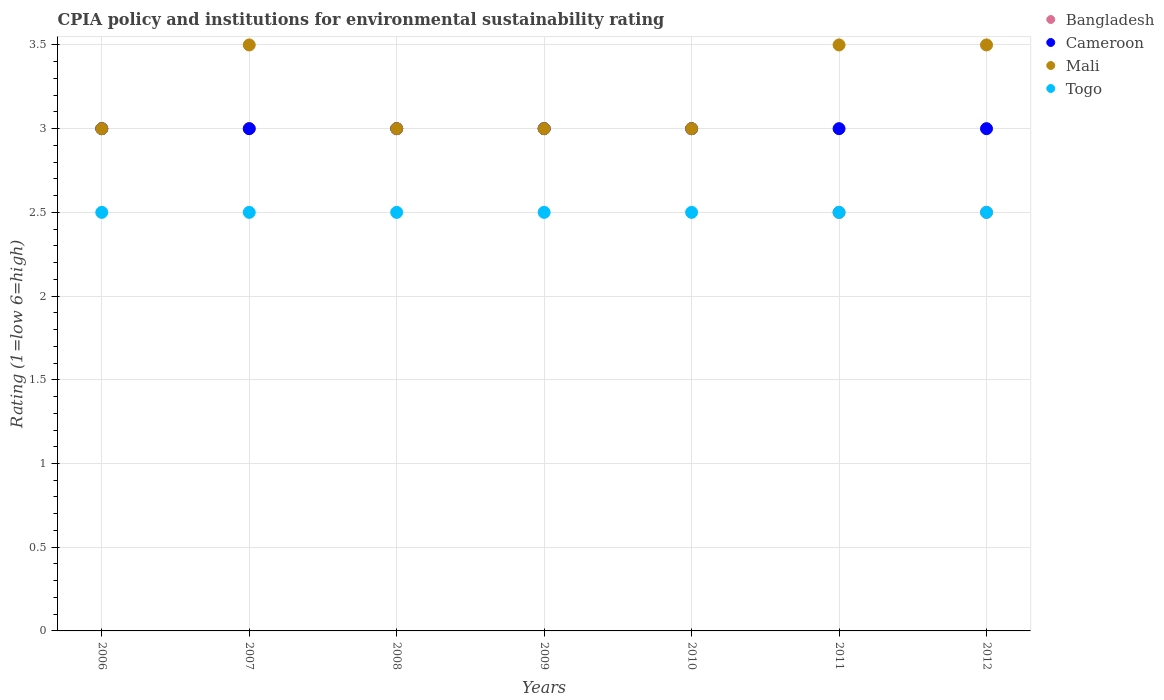Is the number of dotlines equal to the number of legend labels?
Your response must be concise. Yes. What is the CPIA rating in Mali in 2010?
Give a very brief answer. 3. Across all years, what is the maximum CPIA rating in Cameroon?
Provide a short and direct response. 3. Across all years, what is the minimum CPIA rating in Cameroon?
Give a very brief answer. 3. In which year was the CPIA rating in Togo minimum?
Keep it short and to the point. 2006. What is the total CPIA rating in Cameroon in the graph?
Keep it short and to the point. 21. What is the difference between the CPIA rating in Mali in 2011 and the CPIA rating in Togo in 2007?
Your answer should be very brief. 1. In how many years, is the CPIA rating in Bangladesh greater than 3?
Provide a short and direct response. 0. Is the difference between the CPIA rating in Togo in 2006 and 2012 greater than the difference between the CPIA rating in Cameroon in 2006 and 2012?
Give a very brief answer. No. What is the difference between the highest and the lowest CPIA rating in Cameroon?
Provide a succinct answer. 0. Is it the case that in every year, the sum of the CPIA rating in Cameroon and CPIA rating in Mali  is greater than the CPIA rating in Togo?
Offer a very short reply. Yes. Is the CPIA rating in Togo strictly less than the CPIA rating in Mali over the years?
Offer a terse response. Yes. How many dotlines are there?
Your answer should be very brief. 4. Are the values on the major ticks of Y-axis written in scientific E-notation?
Keep it short and to the point. No. Does the graph contain any zero values?
Offer a very short reply. No. Does the graph contain grids?
Your answer should be very brief. Yes. How many legend labels are there?
Your answer should be very brief. 4. What is the title of the graph?
Offer a terse response. CPIA policy and institutions for environmental sustainability rating. What is the Rating (1=low 6=high) in Bangladesh in 2006?
Provide a short and direct response. 3. What is the Rating (1=low 6=high) in Mali in 2006?
Your response must be concise. 3. What is the Rating (1=low 6=high) of Bangladesh in 2007?
Your answer should be compact. 3. What is the Rating (1=low 6=high) of Cameroon in 2008?
Make the answer very short. 3. What is the Rating (1=low 6=high) of Mali in 2008?
Keep it short and to the point. 3. What is the Rating (1=low 6=high) in Togo in 2008?
Ensure brevity in your answer.  2.5. What is the Rating (1=low 6=high) of Cameroon in 2010?
Make the answer very short. 3. What is the Rating (1=low 6=high) of Mali in 2010?
Offer a very short reply. 3. What is the Rating (1=low 6=high) in Togo in 2011?
Ensure brevity in your answer.  2.5. What is the Rating (1=low 6=high) of Cameroon in 2012?
Make the answer very short. 3. What is the Rating (1=low 6=high) of Mali in 2012?
Give a very brief answer. 3.5. Across all years, what is the maximum Rating (1=low 6=high) in Bangladesh?
Make the answer very short. 3. Across all years, what is the maximum Rating (1=low 6=high) in Mali?
Give a very brief answer. 3.5. Across all years, what is the maximum Rating (1=low 6=high) in Togo?
Provide a succinct answer. 2.5. Across all years, what is the minimum Rating (1=low 6=high) in Bangladesh?
Offer a very short reply. 2.5. Across all years, what is the minimum Rating (1=low 6=high) of Cameroon?
Make the answer very short. 3. Across all years, what is the minimum Rating (1=low 6=high) in Mali?
Provide a succinct answer. 3. Across all years, what is the minimum Rating (1=low 6=high) of Togo?
Your answer should be compact. 2.5. What is the total Rating (1=low 6=high) in Cameroon in the graph?
Provide a short and direct response. 21. What is the total Rating (1=low 6=high) in Togo in the graph?
Offer a terse response. 17.5. What is the difference between the Rating (1=low 6=high) of Bangladesh in 2006 and that in 2007?
Provide a short and direct response. 0. What is the difference between the Rating (1=low 6=high) of Cameroon in 2006 and that in 2008?
Provide a succinct answer. 0. What is the difference between the Rating (1=low 6=high) in Mali in 2006 and that in 2008?
Provide a succinct answer. 0. What is the difference between the Rating (1=low 6=high) of Mali in 2006 and that in 2009?
Offer a terse response. 0. What is the difference between the Rating (1=low 6=high) in Cameroon in 2006 and that in 2010?
Ensure brevity in your answer.  0. What is the difference between the Rating (1=low 6=high) in Bangladesh in 2006 and that in 2011?
Your response must be concise. 0.5. What is the difference between the Rating (1=low 6=high) of Togo in 2006 and that in 2011?
Offer a terse response. 0. What is the difference between the Rating (1=low 6=high) in Togo in 2006 and that in 2012?
Your answer should be very brief. 0. What is the difference between the Rating (1=low 6=high) of Mali in 2007 and that in 2008?
Offer a terse response. 0.5. What is the difference between the Rating (1=low 6=high) of Bangladesh in 2007 and that in 2009?
Make the answer very short. 0. What is the difference between the Rating (1=low 6=high) of Togo in 2007 and that in 2009?
Offer a terse response. 0. What is the difference between the Rating (1=low 6=high) in Bangladesh in 2007 and that in 2010?
Your response must be concise. 0. What is the difference between the Rating (1=low 6=high) of Cameroon in 2007 and that in 2010?
Keep it short and to the point. 0. What is the difference between the Rating (1=low 6=high) in Mali in 2007 and that in 2010?
Your response must be concise. 0.5. What is the difference between the Rating (1=low 6=high) in Cameroon in 2007 and that in 2011?
Offer a very short reply. 0. What is the difference between the Rating (1=low 6=high) in Mali in 2007 and that in 2011?
Offer a terse response. 0. What is the difference between the Rating (1=low 6=high) of Togo in 2007 and that in 2011?
Your response must be concise. 0. What is the difference between the Rating (1=low 6=high) in Bangladesh in 2007 and that in 2012?
Your answer should be very brief. 0.5. What is the difference between the Rating (1=low 6=high) of Mali in 2007 and that in 2012?
Your answer should be very brief. 0. What is the difference between the Rating (1=low 6=high) in Cameroon in 2008 and that in 2009?
Your answer should be compact. 0. What is the difference between the Rating (1=low 6=high) of Togo in 2008 and that in 2009?
Give a very brief answer. 0. What is the difference between the Rating (1=low 6=high) of Bangladesh in 2008 and that in 2010?
Your response must be concise. 0. What is the difference between the Rating (1=low 6=high) of Cameroon in 2008 and that in 2010?
Ensure brevity in your answer.  0. What is the difference between the Rating (1=low 6=high) of Mali in 2008 and that in 2010?
Keep it short and to the point. 0. What is the difference between the Rating (1=low 6=high) in Togo in 2008 and that in 2010?
Provide a succinct answer. 0. What is the difference between the Rating (1=low 6=high) of Cameroon in 2008 and that in 2012?
Ensure brevity in your answer.  0. What is the difference between the Rating (1=low 6=high) in Mali in 2008 and that in 2012?
Make the answer very short. -0.5. What is the difference between the Rating (1=low 6=high) of Togo in 2008 and that in 2012?
Your answer should be very brief. 0. What is the difference between the Rating (1=low 6=high) of Cameroon in 2009 and that in 2010?
Ensure brevity in your answer.  0. What is the difference between the Rating (1=low 6=high) in Cameroon in 2009 and that in 2011?
Offer a terse response. 0. What is the difference between the Rating (1=low 6=high) in Mali in 2009 and that in 2011?
Ensure brevity in your answer.  -0.5. What is the difference between the Rating (1=low 6=high) of Togo in 2009 and that in 2011?
Provide a short and direct response. 0. What is the difference between the Rating (1=low 6=high) in Cameroon in 2009 and that in 2012?
Give a very brief answer. 0. What is the difference between the Rating (1=low 6=high) of Togo in 2009 and that in 2012?
Your response must be concise. 0. What is the difference between the Rating (1=low 6=high) of Cameroon in 2010 and that in 2011?
Keep it short and to the point. 0. What is the difference between the Rating (1=low 6=high) of Mali in 2010 and that in 2011?
Provide a succinct answer. -0.5. What is the difference between the Rating (1=low 6=high) in Bangladesh in 2010 and that in 2012?
Your answer should be very brief. 0.5. What is the difference between the Rating (1=low 6=high) in Cameroon in 2010 and that in 2012?
Give a very brief answer. 0. What is the difference between the Rating (1=low 6=high) in Cameroon in 2011 and that in 2012?
Give a very brief answer. 0. What is the difference between the Rating (1=low 6=high) of Bangladesh in 2006 and the Rating (1=low 6=high) of Cameroon in 2007?
Ensure brevity in your answer.  0. What is the difference between the Rating (1=low 6=high) in Bangladesh in 2006 and the Rating (1=low 6=high) in Mali in 2007?
Keep it short and to the point. -0.5. What is the difference between the Rating (1=low 6=high) in Bangladesh in 2006 and the Rating (1=low 6=high) in Togo in 2007?
Your answer should be compact. 0.5. What is the difference between the Rating (1=low 6=high) in Cameroon in 2006 and the Rating (1=low 6=high) in Mali in 2007?
Make the answer very short. -0.5. What is the difference between the Rating (1=low 6=high) in Bangladesh in 2006 and the Rating (1=low 6=high) in Cameroon in 2008?
Your response must be concise. 0. What is the difference between the Rating (1=low 6=high) of Bangladesh in 2006 and the Rating (1=low 6=high) of Mali in 2008?
Provide a short and direct response. 0. What is the difference between the Rating (1=low 6=high) of Cameroon in 2006 and the Rating (1=low 6=high) of Mali in 2008?
Make the answer very short. 0. What is the difference between the Rating (1=low 6=high) in Mali in 2006 and the Rating (1=low 6=high) in Togo in 2008?
Give a very brief answer. 0.5. What is the difference between the Rating (1=low 6=high) in Bangladesh in 2006 and the Rating (1=low 6=high) in Cameroon in 2009?
Provide a short and direct response. 0. What is the difference between the Rating (1=low 6=high) in Bangladesh in 2006 and the Rating (1=low 6=high) in Mali in 2009?
Your response must be concise. 0. What is the difference between the Rating (1=low 6=high) of Bangladesh in 2006 and the Rating (1=low 6=high) of Togo in 2009?
Ensure brevity in your answer.  0.5. What is the difference between the Rating (1=low 6=high) in Cameroon in 2006 and the Rating (1=low 6=high) in Mali in 2009?
Your response must be concise. 0. What is the difference between the Rating (1=low 6=high) of Bangladesh in 2006 and the Rating (1=low 6=high) of Cameroon in 2010?
Provide a succinct answer. 0. What is the difference between the Rating (1=low 6=high) in Bangladesh in 2006 and the Rating (1=low 6=high) in Mali in 2010?
Offer a very short reply. 0. What is the difference between the Rating (1=low 6=high) in Bangladesh in 2006 and the Rating (1=low 6=high) in Togo in 2010?
Give a very brief answer. 0.5. What is the difference between the Rating (1=low 6=high) in Cameroon in 2006 and the Rating (1=low 6=high) in Mali in 2010?
Offer a terse response. 0. What is the difference between the Rating (1=low 6=high) of Mali in 2006 and the Rating (1=low 6=high) of Togo in 2010?
Offer a terse response. 0.5. What is the difference between the Rating (1=low 6=high) of Bangladesh in 2006 and the Rating (1=low 6=high) of Mali in 2011?
Provide a succinct answer. -0.5. What is the difference between the Rating (1=low 6=high) of Cameroon in 2006 and the Rating (1=low 6=high) of Mali in 2011?
Offer a very short reply. -0.5. What is the difference between the Rating (1=low 6=high) of Cameroon in 2006 and the Rating (1=low 6=high) of Togo in 2011?
Your answer should be very brief. 0.5. What is the difference between the Rating (1=low 6=high) in Bangladesh in 2006 and the Rating (1=low 6=high) in Cameroon in 2012?
Provide a succinct answer. 0. What is the difference between the Rating (1=low 6=high) of Bangladesh in 2006 and the Rating (1=low 6=high) of Mali in 2012?
Offer a very short reply. -0.5. What is the difference between the Rating (1=low 6=high) of Bangladesh in 2006 and the Rating (1=low 6=high) of Togo in 2012?
Keep it short and to the point. 0.5. What is the difference between the Rating (1=low 6=high) of Cameroon in 2006 and the Rating (1=low 6=high) of Togo in 2012?
Offer a terse response. 0.5. What is the difference between the Rating (1=low 6=high) of Bangladesh in 2007 and the Rating (1=low 6=high) of Togo in 2008?
Keep it short and to the point. 0.5. What is the difference between the Rating (1=low 6=high) of Cameroon in 2007 and the Rating (1=low 6=high) of Mali in 2008?
Provide a succinct answer. 0. What is the difference between the Rating (1=low 6=high) of Cameroon in 2007 and the Rating (1=low 6=high) of Togo in 2008?
Offer a very short reply. 0.5. What is the difference between the Rating (1=low 6=high) in Bangladesh in 2007 and the Rating (1=low 6=high) in Cameroon in 2010?
Keep it short and to the point. 0. What is the difference between the Rating (1=low 6=high) of Bangladesh in 2007 and the Rating (1=low 6=high) of Mali in 2010?
Ensure brevity in your answer.  0. What is the difference between the Rating (1=low 6=high) of Bangladesh in 2007 and the Rating (1=low 6=high) of Mali in 2011?
Give a very brief answer. -0.5. What is the difference between the Rating (1=low 6=high) in Bangladesh in 2007 and the Rating (1=low 6=high) in Togo in 2011?
Your answer should be compact. 0.5. What is the difference between the Rating (1=low 6=high) in Cameroon in 2007 and the Rating (1=low 6=high) in Mali in 2011?
Your answer should be very brief. -0.5. What is the difference between the Rating (1=low 6=high) of Cameroon in 2007 and the Rating (1=low 6=high) of Mali in 2012?
Your response must be concise. -0.5. What is the difference between the Rating (1=low 6=high) in Cameroon in 2007 and the Rating (1=low 6=high) in Togo in 2012?
Your answer should be very brief. 0.5. What is the difference between the Rating (1=low 6=high) in Mali in 2007 and the Rating (1=low 6=high) in Togo in 2012?
Give a very brief answer. 1. What is the difference between the Rating (1=low 6=high) of Bangladesh in 2008 and the Rating (1=low 6=high) of Cameroon in 2009?
Make the answer very short. 0. What is the difference between the Rating (1=low 6=high) in Cameroon in 2008 and the Rating (1=low 6=high) in Mali in 2009?
Offer a terse response. 0. What is the difference between the Rating (1=low 6=high) in Bangladesh in 2008 and the Rating (1=low 6=high) in Togo in 2010?
Offer a very short reply. 0.5. What is the difference between the Rating (1=low 6=high) of Cameroon in 2008 and the Rating (1=low 6=high) of Mali in 2010?
Ensure brevity in your answer.  0. What is the difference between the Rating (1=low 6=high) in Mali in 2008 and the Rating (1=low 6=high) in Togo in 2010?
Ensure brevity in your answer.  0.5. What is the difference between the Rating (1=low 6=high) of Bangladesh in 2008 and the Rating (1=low 6=high) of Cameroon in 2011?
Keep it short and to the point. 0. What is the difference between the Rating (1=low 6=high) of Bangladesh in 2008 and the Rating (1=low 6=high) of Mali in 2011?
Provide a succinct answer. -0.5. What is the difference between the Rating (1=low 6=high) in Mali in 2008 and the Rating (1=low 6=high) in Togo in 2011?
Keep it short and to the point. 0.5. What is the difference between the Rating (1=low 6=high) in Bangladesh in 2008 and the Rating (1=low 6=high) in Mali in 2012?
Your response must be concise. -0.5. What is the difference between the Rating (1=low 6=high) in Bangladesh in 2008 and the Rating (1=low 6=high) in Togo in 2012?
Offer a very short reply. 0.5. What is the difference between the Rating (1=low 6=high) in Cameroon in 2008 and the Rating (1=low 6=high) in Togo in 2012?
Ensure brevity in your answer.  0.5. What is the difference between the Rating (1=low 6=high) of Mali in 2008 and the Rating (1=low 6=high) of Togo in 2012?
Make the answer very short. 0.5. What is the difference between the Rating (1=low 6=high) in Bangladesh in 2009 and the Rating (1=low 6=high) in Cameroon in 2010?
Provide a short and direct response. 0. What is the difference between the Rating (1=low 6=high) in Cameroon in 2009 and the Rating (1=low 6=high) in Mali in 2010?
Your response must be concise. 0. What is the difference between the Rating (1=low 6=high) of Mali in 2009 and the Rating (1=low 6=high) of Togo in 2010?
Provide a short and direct response. 0.5. What is the difference between the Rating (1=low 6=high) in Bangladesh in 2009 and the Rating (1=low 6=high) in Mali in 2011?
Give a very brief answer. -0.5. What is the difference between the Rating (1=low 6=high) in Cameroon in 2009 and the Rating (1=low 6=high) in Mali in 2011?
Provide a short and direct response. -0.5. What is the difference between the Rating (1=low 6=high) in Cameroon in 2009 and the Rating (1=low 6=high) in Togo in 2011?
Give a very brief answer. 0.5. What is the difference between the Rating (1=low 6=high) in Bangladesh in 2009 and the Rating (1=low 6=high) in Cameroon in 2012?
Give a very brief answer. 0. What is the difference between the Rating (1=low 6=high) of Bangladesh in 2009 and the Rating (1=low 6=high) of Mali in 2012?
Give a very brief answer. -0.5. What is the difference between the Rating (1=low 6=high) of Bangladesh in 2009 and the Rating (1=low 6=high) of Togo in 2012?
Your answer should be compact. 0.5. What is the difference between the Rating (1=low 6=high) in Cameroon in 2009 and the Rating (1=low 6=high) in Mali in 2012?
Provide a succinct answer. -0.5. What is the difference between the Rating (1=low 6=high) in Mali in 2009 and the Rating (1=low 6=high) in Togo in 2012?
Your answer should be compact. 0.5. What is the difference between the Rating (1=low 6=high) of Bangladesh in 2010 and the Rating (1=low 6=high) of Cameroon in 2011?
Ensure brevity in your answer.  0. What is the difference between the Rating (1=low 6=high) of Bangladesh in 2010 and the Rating (1=low 6=high) of Mali in 2011?
Provide a succinct answer. -0.5. What is the difference between the Rating (1=low 6=high) in Cameroon in 2010 and the Rating (1=low 6=high) in Mali in 2011?
Offer a very short reply. -0.5. What is the difference between the Rating (1=low 6=high) in Bangladesh in 2010 and the Rating (1=low 6=high) in Mali in 2012?
Your answer should be very brief. -0.5. What is the difference between the Rating (1=low 6=high) in Bangladesh in 2010 and the Rating (1=low 6=high) in Togo in 2012?
Your response must be concise. 0.5. What is the difference between the Rating (1=low 6=high) in Bangladesh in 2011 and the Rating (1=low 6=high) in Mali in 2012?
Give a very brief answer. -1. What is the difference between the Rating (1=low 6=high) in Mali in 2011 and the Rating (1=low 6=high) in Togo in 2012?
Provide a short and direct response. 1. What is the average Rating (1=low 6=high) of Bangladesh per year?
Give a very brief answer. 2.86. What is the average Rating (1=low 6=high) of Mali per year?
Provide a succinct answer. 3.21. In the year 2006, what is the difference between the Rating (1=low 6=high) in Bangladesh and Rating (1=low 6=high) in Togo?
Ensure brevity in your answer.  0.5. In the year 2006, what is the difference between the Rating (1=low 6=high) in Cameroon and Rating (1=low 6=high) in Togo?
Ensure brevity in your answer.  0.5. In the year 2006, what is the difference between the Rating (1=low 6=high) of Mali and Rating (1=low 6=high) of Togo?
Offer a terse response. 0.5. In the year 2007, what is the difference between the Rating (1=low 6=high) in Bangladesh and Rating (1=low 6=high) in Cameroon?
Keep it short and to the point. 0. In the year 2007, what is the difference between the Rating (1=low 6=high) in Bangladesh and Rating (1=low 6=high) in Togo?
Give a very brief answer. 0.5. In the year 2007, what is the difference between the Rating (1=low 6=high) of Cameroon and Rating (1=low 6=high) of Mali?
Give a very brief answer. -0.5. In the year 2008, what is the difference between the Rating (1=low 6=high) of Bangladesh and Rating (1=low 6=high) of Mali?
Your answer should be very brief. 0. In the year 2008, what is the difference between the Rating (1=low 6=high) of Cameroon and Rating (1=low 6=high) of Mali?
Make the answer very short. 0. In the year 2008, what is the difference between the Rating (1=low 6=high) in Cameroon and Rating (1=low 6=high) in Togo?
Your answer should be very brief. 0.5. In the year 2008, what is the difference between the Rating (1=low 6=high) of Mali and Rating (1=low 6=high) of Togo?
Keep it short and to the point. 0.5. In the year 2009, what is the difference between the Rating (1=low 6=high) of Bangladesh and Rating (1=low 6=high) of Mali?
Provide a short and direct response. 0. In the year 2009, what is the difference between the Rating (1=low 6=high) of Cameroon and Rating (1=low 6=high) of Mali?
Your response must be concise. 0. In the year 2009, what is the difference between the Rating (1=low 6=high) in Cameroon and Rating (1=low 6=high) in Togo?
Offer a terse response. 0.5. In the year 2009, what is the difference between the Rating (1=low 6=high) in Mali and Rating (1=low 6=high) in Togo?
Provide a short and direct response. 0.5. In the year 2010, what is the difference between the Rating (1=low 6=high) in Bangladesh and Rating (1=low 6=high) in Cameroon?
Your response must be concise. 0. In the year 2010, what is the difference between the Rating (1=low 6=high) in Cameroon and Rating (1=low 6=high) in Mali?
Your response must be concise. 0. In the year 2010, what is the difference between the Rating (1=low 6=high) of Mali and Rating (1=low 6=high) of Togo?
Provide a succinct answer. 0.5. In the year 2011, what is the difference between the Rating (1=low 6=high) of Bangladesh and Rating (1=low 6=high) of Mali?
Your answer should be very brief. -1. In the year 2011, what is the difference between the Rating (1=low 6=high) of Bangladesh and Rating (1=low 6=high) of Togo?
Offer a very short reply. 0. In the year 2011, what is the difference between the Rating (1=low 6=high) of Cameroon and Rating (1=low 6=high) of Mali?
Give a very brief answer. -0.5. In the year 2012, what is the difference between the Rating (1=low 6=high) in Cameroon and Rating (1=low 6=high) in Mali?
Provide a succinct answer. -0.5. What is the ratio of the Rating (1=low 6=high) in Bangladesh in 2006 to that in 2007?
Make the answer very short. 1. What is the ratio of the Rating (1=low 6=high) in Mali in 2006 to that in 2007?
Make the answer very short. 0.86. What is the ratio of the Rating (1=low 6=high) in Bangladesh in 2006 to that in 2008?
Keep it short and to the point. 1. What is the ratio of the Rating (1=low 6=high) in Mali in 2006 to that in 2008?
Ensure brevity in your answer.  1. What is the ratio of the Rating (1=low 6=high) of Togo in 2006 to that in 2008?
Provide a short and direct response. 1. What is the ratio of the Rating (1=low 6=high) in Bangladesh in 2006 to that in 2009?
Provide a short and direct response. 1. What is the ratio of the Rating (1=low 6=high) in Togo in 2006 to that in 2009?
Offer a very short reply. 1. What is the ratio of the Rating (1=low 6=high) of Cameroon in 2006 to that in 2010?
Give a very brief answer. 1. What is the ratio of the Rating (1=low 6=high) in Togo in 2006 to that in 2010?
Provide a succinct answer. 1. What is the ratio of the Rating (1=low 6=high) in Cameroon in 2006 to that in 2011?
Offer a very short reply. 1. What is the ratio of the Rating (1=low 6=high) in Togo in 2006 to that in 2011?
Provide a succinct answer. 1. What is the ratio of the Rating (1=low 6=high) of Bangladesh in 2006 to that in 2012?
Your response must be concise. 1.2. What is the ratio of the Rating (1=low 6=high) in Cameroon in 2006 to that in 2012?
Provide a succinct answer. 1. What is the ratio of the Rating (1=low 6=high) in Togo in 2006 to that in 2012?
Offer a terse response. 1. What is the ratio of the Rating (1=low 6=high) in Mali in 2007 to that in 2008?
Your answer should be very brief. 1.17. What is the ratio of the Rating (1=low 6=high) in Togo in 2007 to that in 2008?
Give a very brief answer. 1. What is the ratio of the Rating (1=low 6=high) in Mali in 2007 to that in 2009?
Your answer should be compact. 1.17. What is the ratio of the Rating (1=low 6=high) of Bangladesh in 2007 to that in 2010?
Offer a very short reply. 1. What is the ratio of the Rating (1=low 6=high) in Mali in 2007 to that in 2010?
Offer a very short reply. 1.17. What is the ratio of the Rating (1=low 6=high) in Togo in 2007 to that in 2010?
Provide a succinct answer. 1. What is the ratio of the Rating (1=low 6=high) in Cameroon in 2007 to that in 2011?
Your answer should be very brief. 1. What is the ratio of the Rating (1=low 6=high) of Togo in 2007 to that in 2011?
Ensure brevity in your answer.  1. What is the ratio of the Rating (1=low 6=high) in Bangladesh in 2007 to that in 2012?
Your response must be concise. 1.2. What is the ratio of the Rating (1=low 6=high) in Togo in 2007 to that in 2012?
Your answer should be compact. 1. What is the ratio of the Rating (1=low 6=high) in Cameroon in 2008 to that in 2009?
Offer a terse response. 1. What is the ratio of the Rating (1=low 6=high) in Mali in 2008 to that in 2009?
Your answer should be compact. 1. What is the ratio of the Rating (1=low 6=high) in Togo in 2008 to that in 2009?
Ensure brevity in your answer.  1. What is the ratio of the Rating (1=low 6=high) in Togo in 2008 to that in 2010?
Make the answer very short. 1. What is the ratio of the Rating (1=low 6=high) of Bangladesh in 2008 to that in 2011?
Your answer should be very brief. 1.2. What is the ratio of the Rating (1=low 6=high) of Mali in 2008 to that in 2011?
Offer a terse response. 0.86. What is the ratio of the Rating (1=low 6=high) in Togo in 2008 to that in 2011?
Keep it short and to the point. 1. What is the ratio of the Rating (1=low 6=high) in Bangladesh in 2008 to that in 2012?
Provide a succinct answer. 1.2. What is the ratio of the Rating (1=low 6=high) of Cameroon in 2008 to that in 2012?
Offer a terse response. 1. What is the ratio of the Rating (1=low 6=high) in Mali in 2008 to that in 2012?
Offer a very short reply. 0.86. What is the ratio of the Rating (1=low 6=high) in Cameroon in 2009 to that in 2010?
Your answer should be very brief. 1. What is the ratio of the Rating (1=low 6=high) of Togo in 2009 to that in 2010?
Your answer should be very brief. 1. What is the ratio of the Rating (1=low 6=high) of Bangladesh in 2009 to that in 2011?
Provide a short and direct response. 1.2. What is the ratio of the Rating (1=low 6=high) of Cameroon in 2009 to that in 2011?
Offer a terse response. 1. What is the ratio of the Rating (1=low 6=high) of Mali in 2009 to that in 2011?
Your answer should be compact. 0.86. What is the ratio of the Rating (1=low 6=high) of Togo in 2009 to that in 2011?
Give a very brief answer. 1. What is the ratio of the Rating (1=low 6=high) of Bangladesh in 2009 to that in 2012?
Offer a terse response. 1.2. What is the ratio of the Rating (1=low 6=high) of Togo in 2009 to that in 2012?
Provide a short and direct response. 1. What is the ratio of the Rating (1=low 6=high) in Bangladesh in 2010 to that in 2011?
Offer a terse response. 1.2. What is the ratio of the Rating (1=low 6=high) of Mali in 2010 to that in 2011?
Offer a terse response. 0.86. What is the ratio of the Rating (1=low 6=high) of Togo in 2010 to that in 2011?
Ensure brevity in your answer.  1. What is the ratio of the Rating (1=low 6=high) of Bangladesh in 2010 to that in 2012?
Your answer should be very brief. 1.2. What is the ratio of the Rating (1=low 6=high) of Bangladesh in 2011 to that in 2012?
Make the answer very short. 1. What is the difference between the highest and the second highest Rating (1=low 6=high) of Bangladesh?
Offer a terse response. 0. What is the difference between the highest and the second highest Rating (1=low 6=high) of Cameroon?
Ensure brevity in your answer.  0. What is the difference between the highest and the second highest Rating (1=low 6=high) in Mali?
Provide a short and direct response. 0. What is the difference between the highest and the second highest Rating (1=low 6=high) of Togo?
Your answer should be compact. 0. What is the difference between the highest and the lowest Rating (1=low 6=high) of Bangladesh?
Offer a very short reply. 0.5. What is the difference between the highest and the lowest Rating (1=low 6=high) in Cameroon?
Offer a very short reply. 0. What is the difference between the highest and the lowest Rating (1=low 6=high) in Togo?
Your answer should be compact. 0. 